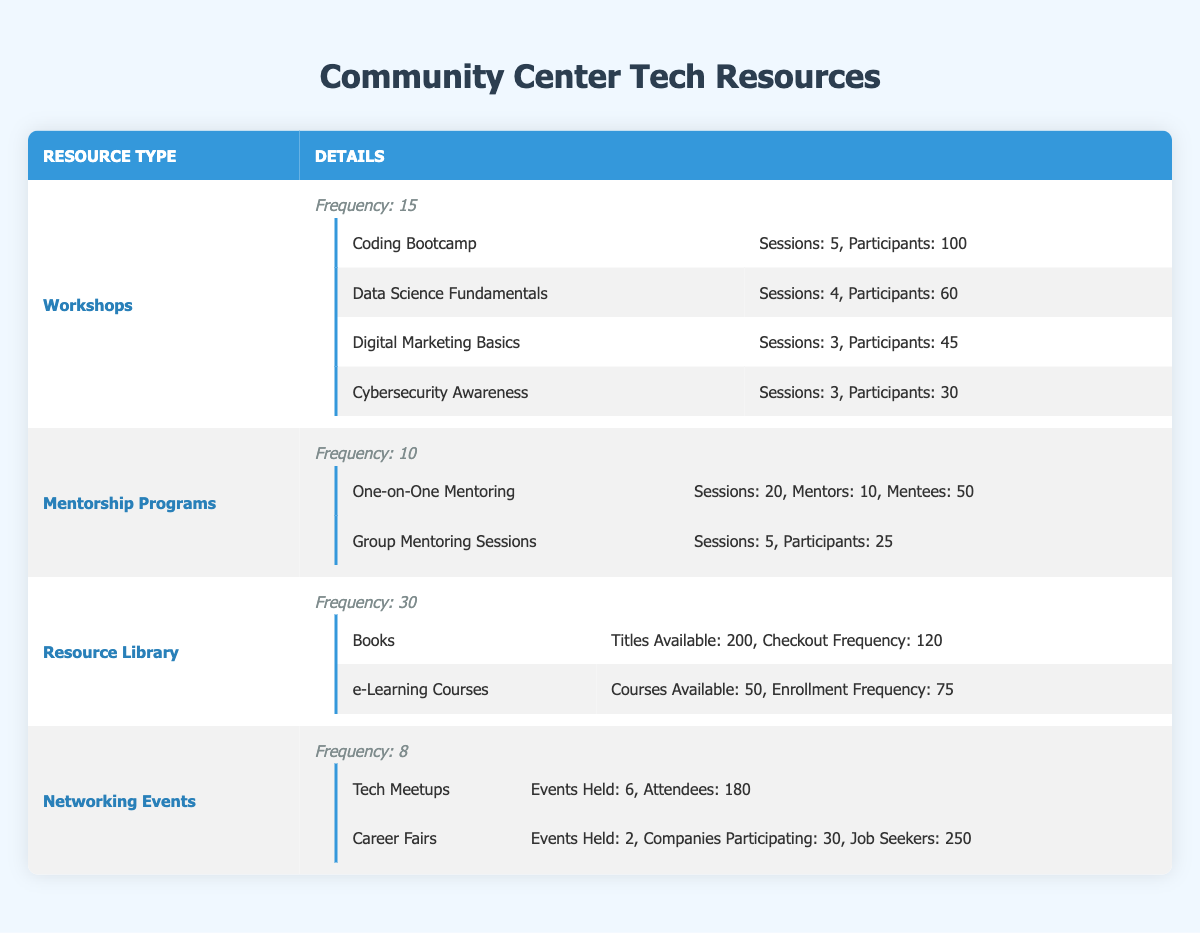What is the total number of sessions for Workshops? To find the total number of sessions for Workshops, I will sum the sessions for each workshop type listed. Coding Bootcamp has 5 sessions, Data Science Fundamentals has 4 sessions, Digital Marketing Basics has 3 sessions, and Cybersecurity Awareness has 3 sessions. Therefore, the total is 5 + 4 + 3 + 3 = 15.
Answer: 15 How many participants attended the Data Science Fundamentals workshop? According to the table, the Data Science Fundamentals workshop had 60 participants. This information is directly listed under the details of the workshop.
Answer: 60 Is the frequency of Networking Events greater than that of Mentorship Programs? The frequency of Networking Events is 8 and the frequency of Mentorship Programs is 10. Since 8 is less than 10, the statement is false.
Answer: No What is the total number of mentors and mentees involved in the One-on-One Mentoring? To find this total, I need to add the number of mentors and mentees. There are 10 mentors and 50 mentees. Thus, the total is 10 + 50 = 60.
Answer: 60 Which resource has the highest frequency of usage? Reviewing the frequencies listed, the Resource Library shows a frequency of 30, which is higher than all other resources. Workshops have a frequency of 15, Mentorship Programs 10, and Networking Events 8. Thus, the Resource Library has the highest frequency.
Answer: Resource Library What is the combined number of participants for all workshops? To get the combined number of participants for all workshops, I add the participants from each workshop type: 100 (Coding Bootcamp) + 60 (Data Science Fundamentals) + 45 (Digital Marketing Basics) + 30 (Cybersecurity Awareness) = 335.
Answer: 335 How many more job seekers attended the Career Fair compared to Tech Meetups? The number of job seekers at the Career Fair is 250, and the number of attendees at Tech Meetups is 180. To find the difference, I subtract the attendees at Tech Meetups from the job seekers at the Career Fair: 250 - 180 = 70.
Answer: 70 What is the ratio of sessions conducted in the Workshop section to the total sessions in Mentorship Programs? The total sessions in the Workshops section is 15, and in the Mentorship Programs, there are 20 sessions in One-on-One Mentoring and 5 in Group Mentoring, totaling 25. The ratio of workshops sessions to mentorship sessions is 15:25. Simplifying this gives us 3:5.
Answer: 3:5 